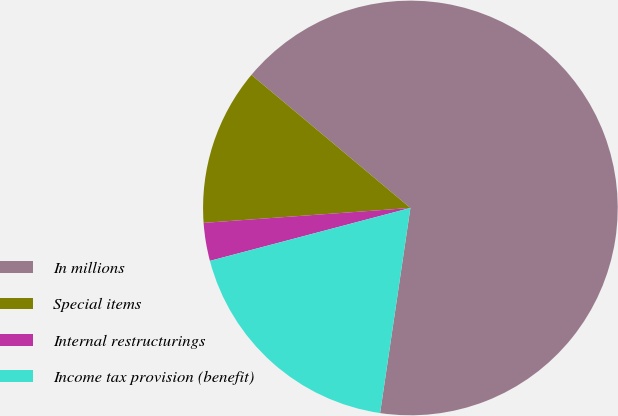Convert chart. <chart><loc_0><loc_0><loc_500><loc_500><pie_chart><fcel>In millions<fcel>Special items<fcel>Internal restructurings<fcel>Income tax provision (benefit)<nl><fcel>66.24%<fcel>12.24%<fcel>2.96%<fcel>18.56%<nl></chart> 